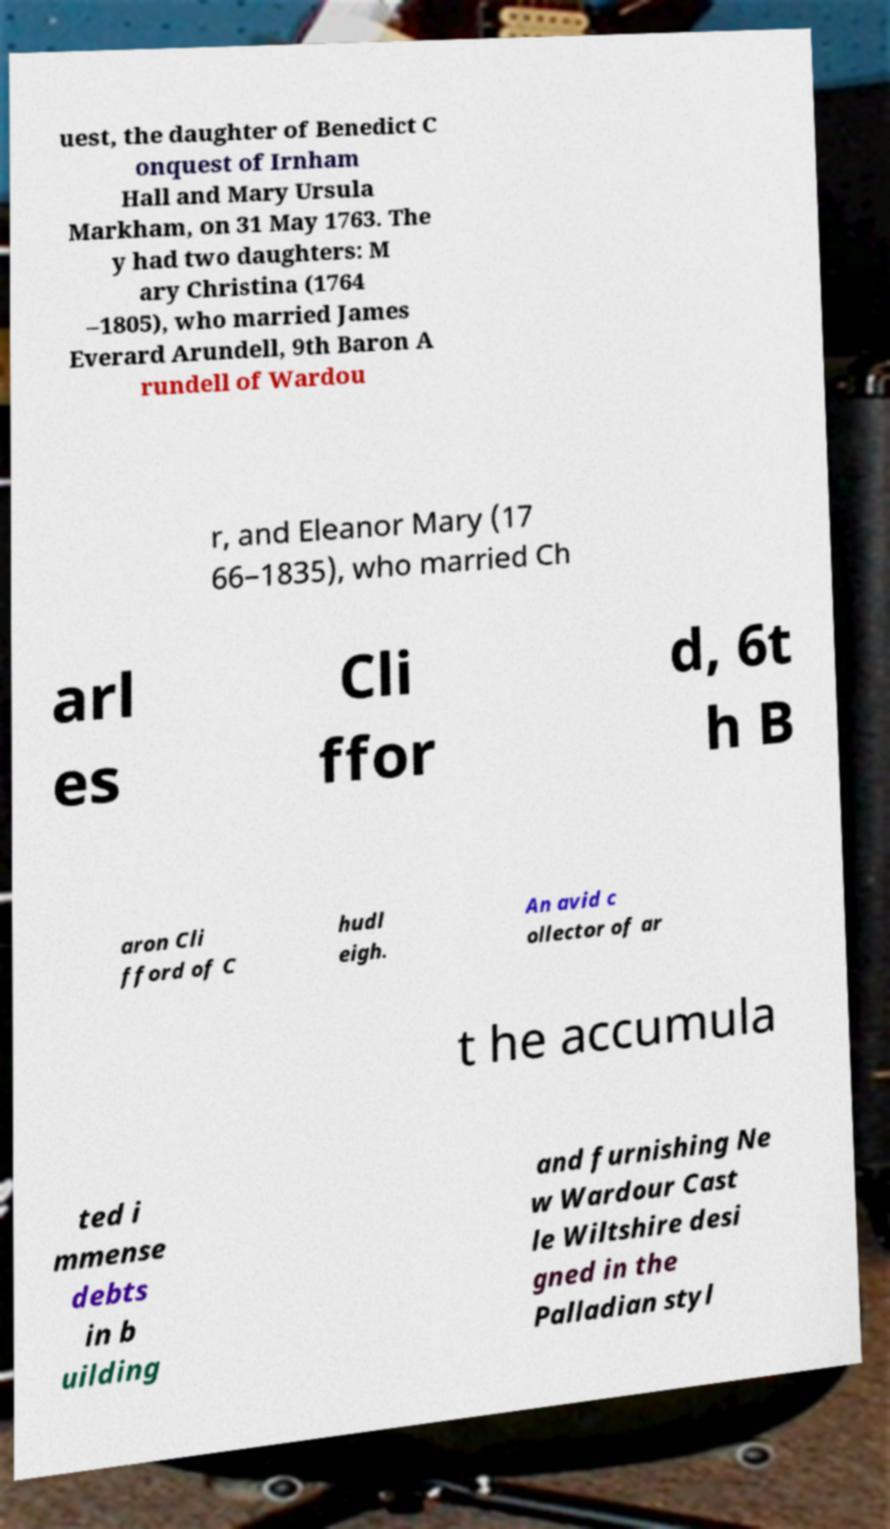Please read and relay the text visible in this image. What does it say? uest, the daughter of Benedict C onquest of Irnham Hall and Mary Ursula Markham, on 31 May 1763. The y had two daughters: M ary Christina (1764 –1805), who married James Everard Arundell, 9th Baron A rundell of Wardou r, and Eleanor Mary (17 66–1835), who married Ch arl es Cli ffor d, 6t h B aron Cli fford of C hudl eigh. An avid c ollector of ar t he accumula ted i mmense debts in b uilding and furnishing Ne w Wardour Cast le Wiltshire desi gned in the Palladian styl 